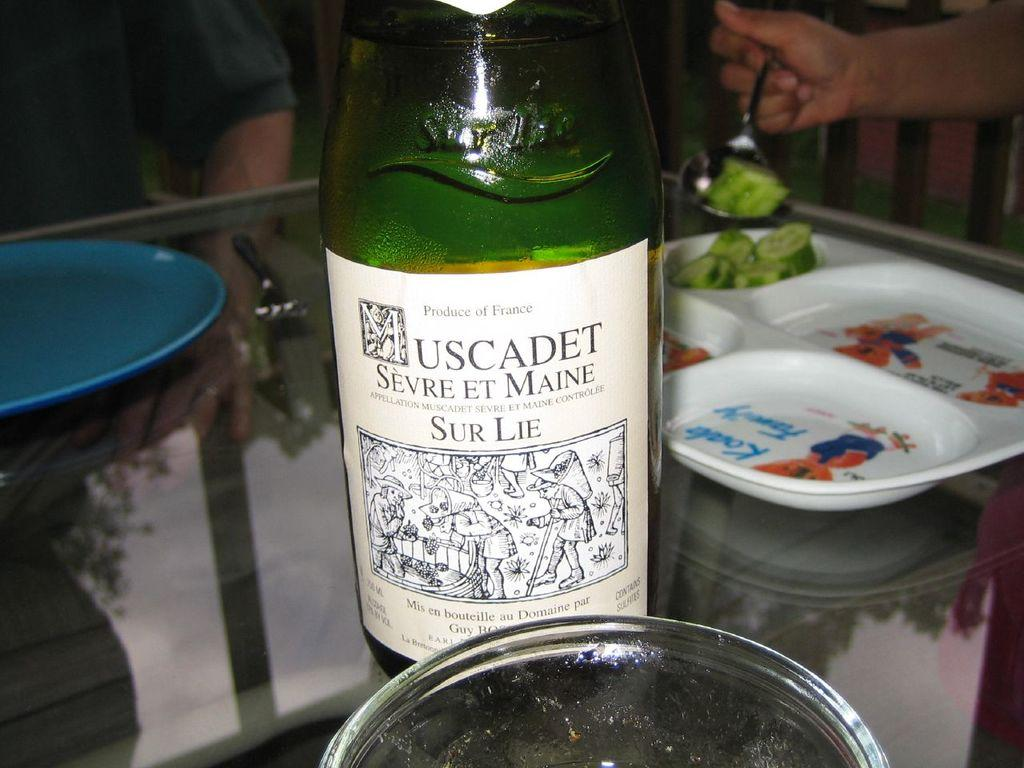<image>
Provide a brief description of the given image. a bottle of Muscadet is sitting on the table 